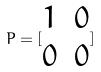Convert formula to latex. <formula><loc_0><loc_0><loc_500><loc_500>P = [ \begin{matrix} 1 & 0 \\ 0 & 0 \end{matrix} ]</formula> 